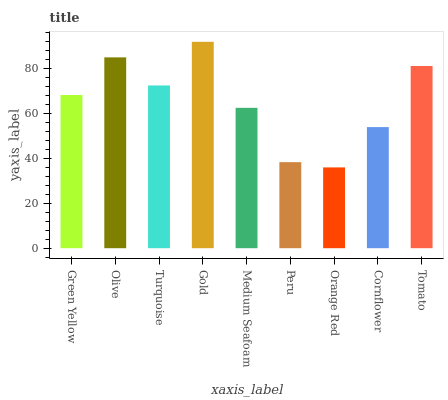Is Orange Red the minimum?
Answer yes or no. Yes. Is Gold the maximum?
Answer yes or no. Yes. Is Olive the minimum?
Answer yes or no. No. Is Olive the maximum?
Answer yes or no. No. Is Olive greater than Green Yellow?
Answer yes or no. Yes. Is Green Yellow less than Olive?
Answer yes or no. Yes. Is Green Yellow greater than Olive?
Answer yes or no. No. Is Olive less than Green Yellow?
Answer yes or no. No. Is Green Yellow the high median?
Answer yes or no. Yes. Is Green Yellow the low median?
Answer yes or no. Yes. Is Gold the high median?
Answer yes or no. No. Is Medium Seafoam the low median?
Answer yes or no. No. 